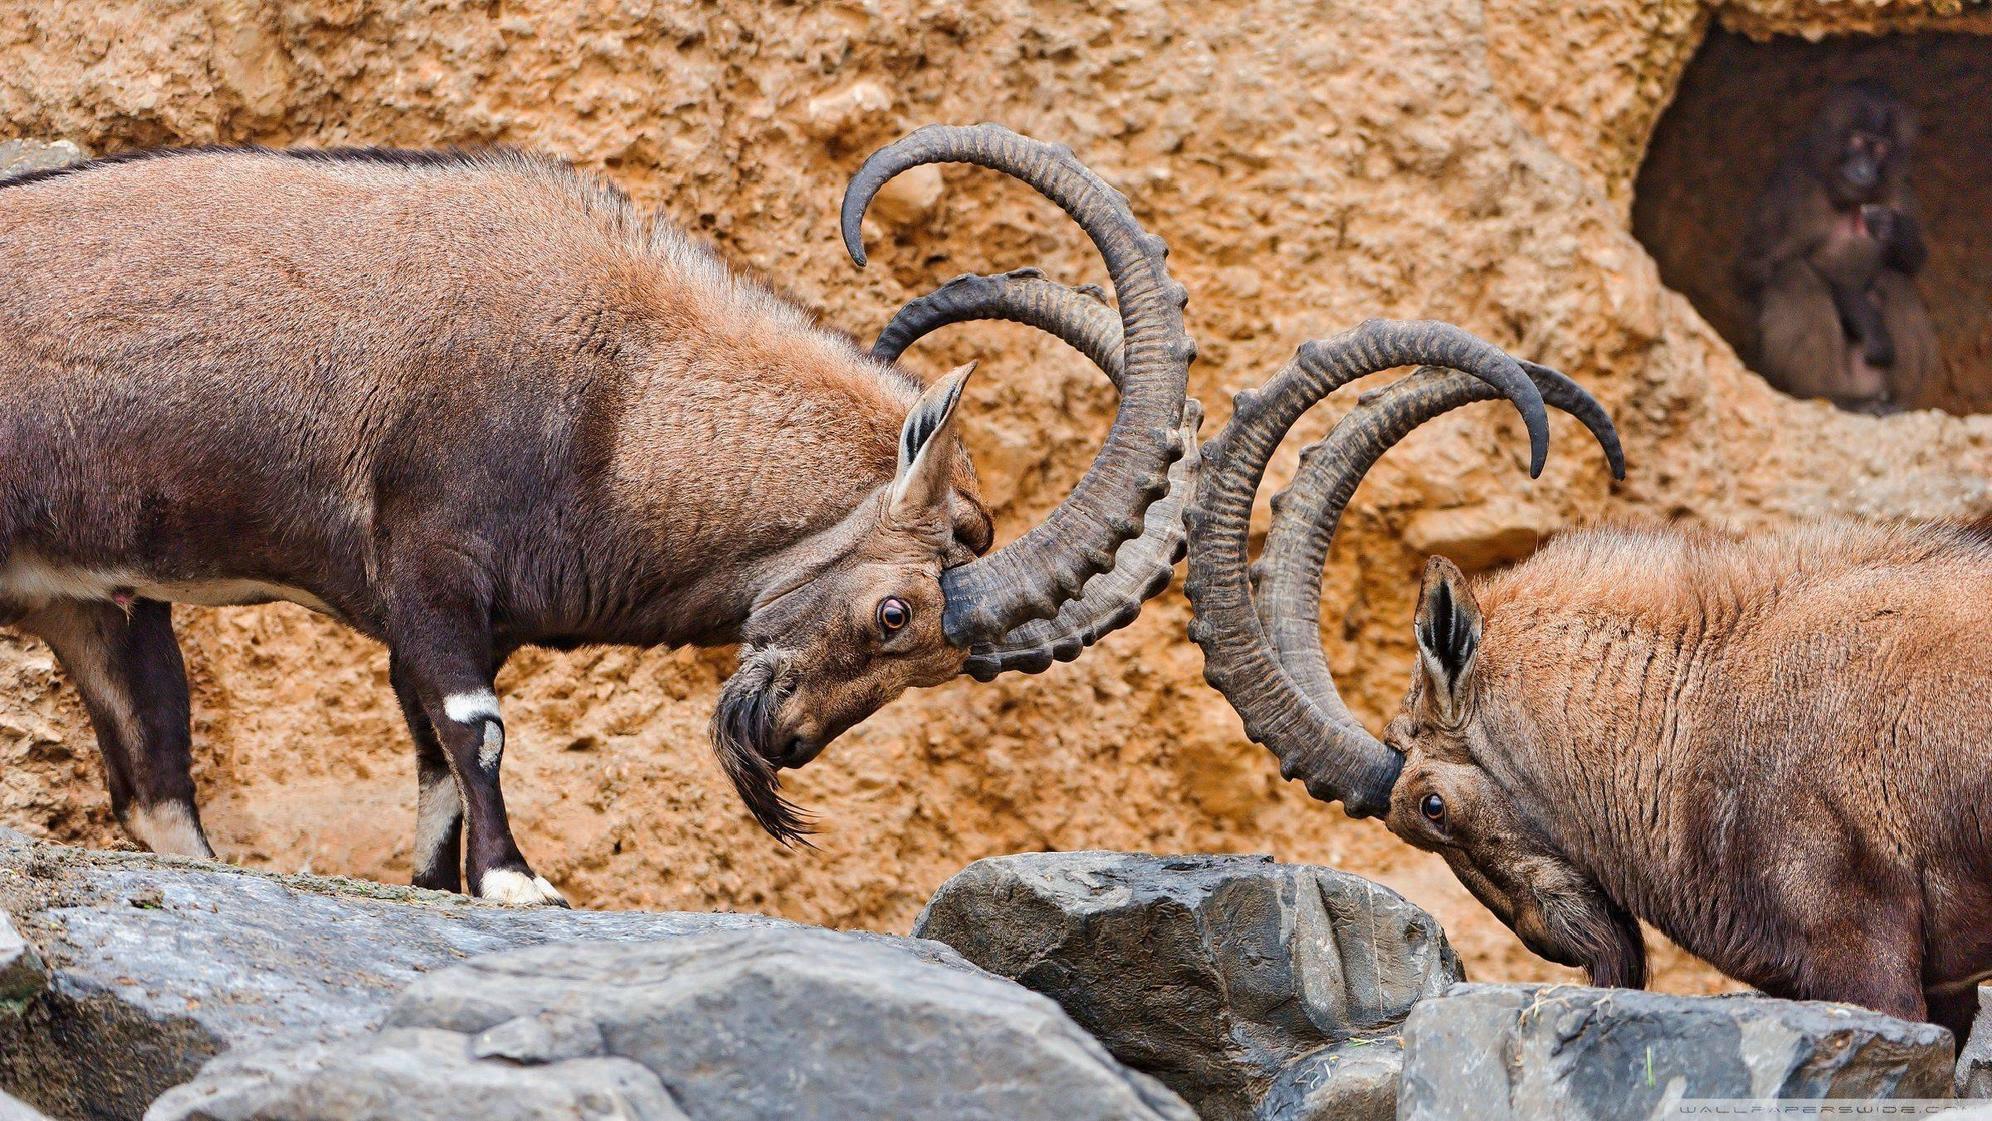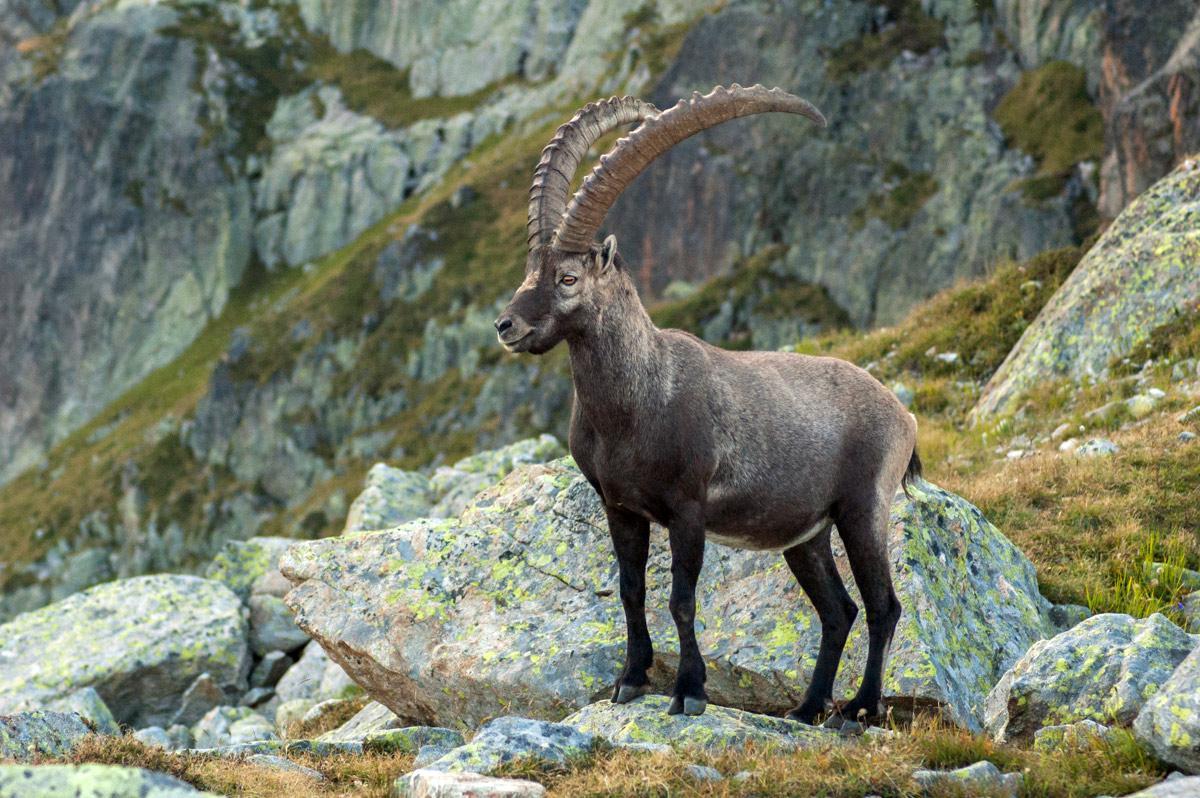The first image is the image on the left, the second image is the image on the right. Evaluate the accuracy of this statement regarding the images: "One image shows multiple antelope on a sheer rock wall bare of any foliage.". Is it true? Answer yes or no. No. 